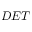<formula> <loc_0><loc_0><loc_500><loc_500>D E T</formula> 